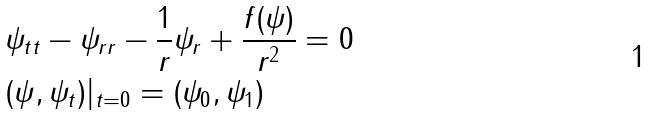Convert formula to latex. <formula><loc_0><loc_0><loc_500><loc_500>& \psi _ { t t } - \psi _ { r r } - \frac { 1 } { r } \psi _ { r } + \frac { f ( \psi ) } { r ^ { 2 } } = 0 \\ & ( \psi , \psi _ { t } ) | _ { t = 0 } = ( \psi _ { 0 } , \psi _ { 1 } )</formula> 